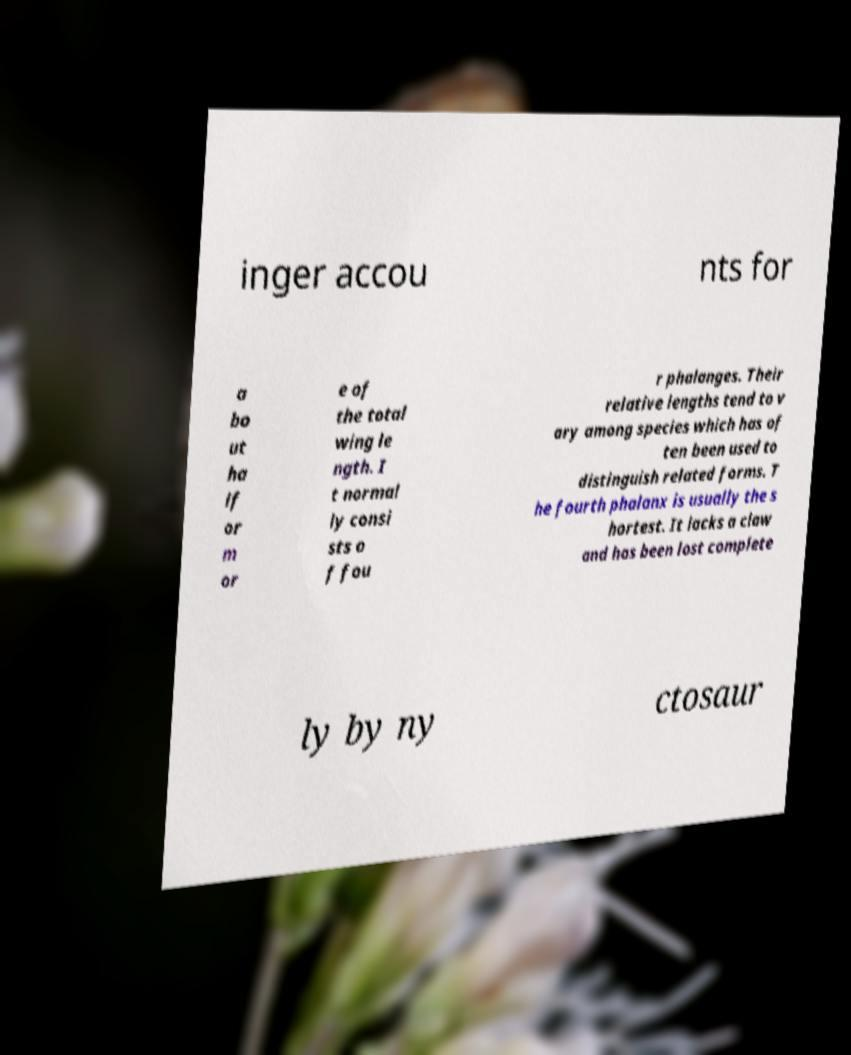For documentation purposes, I need the text within this image transcribed. Could you provide that? inger accou nts for a bo ut ha lf or m or e of the total wing le ngth. I t normal ly consi sts o f fou r phalanges. Their relative lengths tend to v ary among species which has of ten been used to distinguish related forms. T he fourth phalanx is usually the s hortest. It lacks a claw and has been lost complete ly by ny ctosaur 